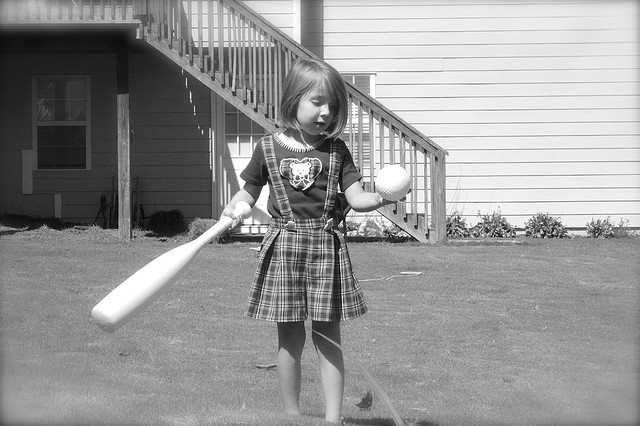Describe the objects in this image and their specific colors. I can see people in gray, darkgray, black, and lightgray tones, baseball bat in darkgray, lightgray, gray, and white tones, and sports ball in gray, white, darkgray, and black tones in this image. 